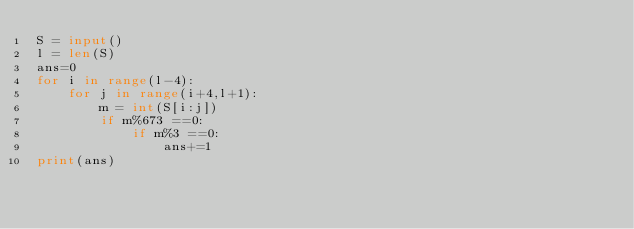Convert code to text. <code><loc_0><loc_0><loc_500><loc_500><_Python_>S = input()
l = len(S)
ans=0
for i in range(l-4):
    for j in range(i+4,l+1):
        m = int(S[i:j])
        if m%673 ==0:
            if m%3 ==0:
                ans+=1
print(ans)</code> 